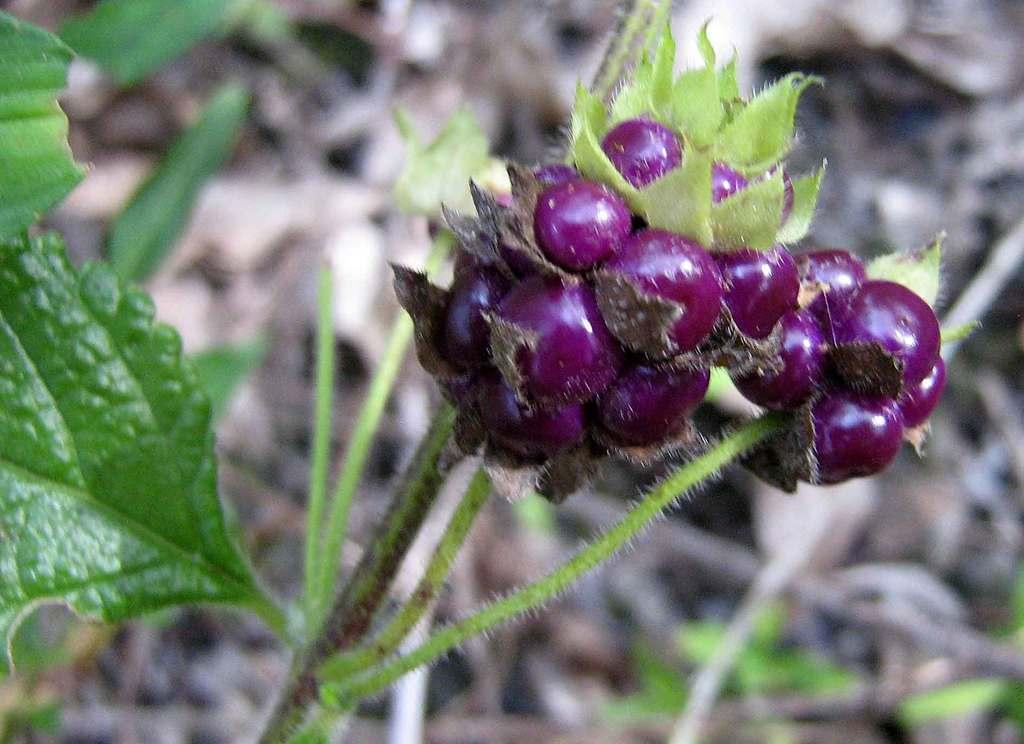What type of food can be seen in the image? There are fruits in the image. What else is present in the image besides the fruits? There are leaves in the image. How many brothers are present at the party in the image? There is no party or brothers present in the image; it only features fruits and leaves. What type of bird can be seen in the image? There is no bird present in the image; it only features fruits and leaves. 